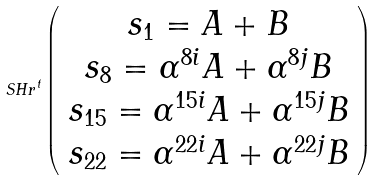<formula> <loc_0><loc_0><loc_500><loc_500>S H r ^ { t } \left ( \begin{array} { c } s _ { 1 } = A + B \\ s _ { 8 } = \alpha ^ { 8 i } A + \alpha ^ { 8 j } B \\ s _ { 1 5 } = \alpha ^ { 1 5 i } A + \alpha ^ { 1 5 j } B \\ s _ { 2 2 } = \alpha ^ { 2 2 i } A + \alpha ^ { 2 2 j } B \end{array} \right )</formula> 